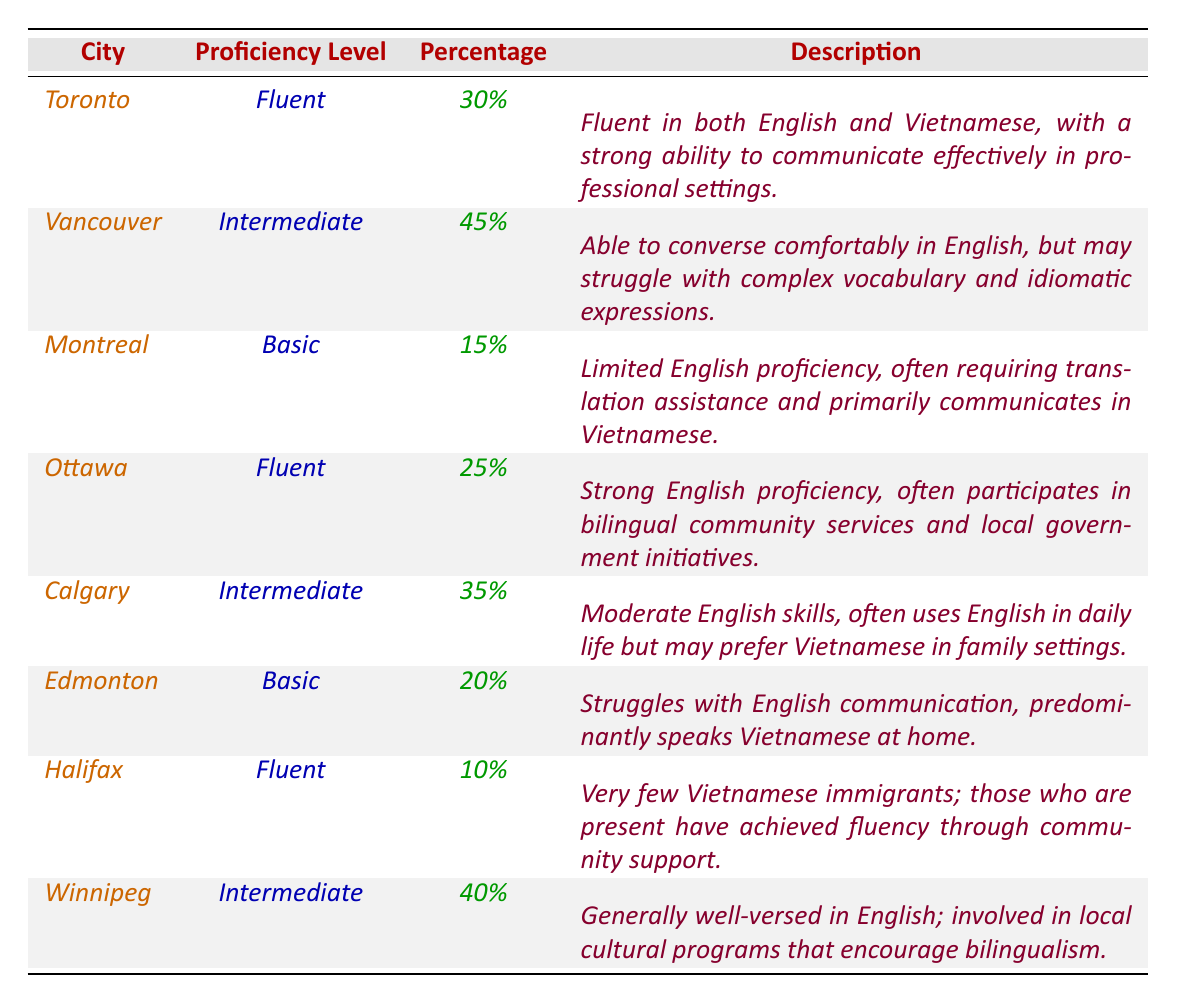What is the proficiency level of Vietnamese immigrants in Montreal? According to the table, the proficiency level of Vietnamese immigrants in Montreal is noted as "Basic."
Answer: Basic Which city has the highest percentage of Vietnamese immigrants with intermediate proficiency? From the table, Vancouver has the highest percentage of Vietnamese immigrants with intermediate proficiency at 45%.
Answer: Vancouver What percentage of Vietnamese immigrants in Ottawa are fluent in English? The table shows that 25% of Vietnamese immigrants in Ottawa are fluent in English.
Answer: 25% Is the statement "Fluent Vietnamese immigrants are less than 30% in Toronto" true or false? The table indicates that 30% of Vietnamese immigrants in Toronto are fluent, meaning the statement is false.
Answer: False What is the average percentage of Vietnamese immigrants who are at a basic proficiency level across the cities? To find the average, we look at the percentages for basic proficiency: 15% (Montreal) + 20% (Edmonton) = 35%. There are 2 cities, so the average is 35% / 2 = 17.5%.
Answer: 17.5% How many cities have a fluency percentage greater than 20%? Observing the table, we see that Toronto (30%), Ottawa (25%), and Halifax (10%) have fluency percentages. Only Toronto and Ottawa exceed 20%. Thus, there are 2 cities.
Answer: 2 Which city has the lowest percentage of Vietnamese immigrants who are fluent? From the table, Halifax has the lowest percentage of fluent Vietnamese immigrants at only 10%.
Answer: Halifax What would be the total percentage of Vietnamese immigrants in Calgary and Edmonton who are at an intermediate proficiency level? Looking at the table, Calgary has an intermediate proficiency percentage of 35% and Edmonton does not have an intermediate level. Therefore, we consider only Calgary's value: 35%.
Answer: 35% Which city has the same proficiency level as Winnipeg for Vietnamese immigrants? The table indicates that both Winnipeg and Vancouver have an intermediate proficiency level at 40% and 45%, respectively. Therefore, there are no cities with the same level.
Answer: None What is the combined percentage of immigrants with fluent proficiency in both Toronto and Ottawa? From the table, Toronto has 30% and Ottawa has 25% of fluent immigrants. Adding these gives: 30% + 25% = 55%.
Answer: 55% 